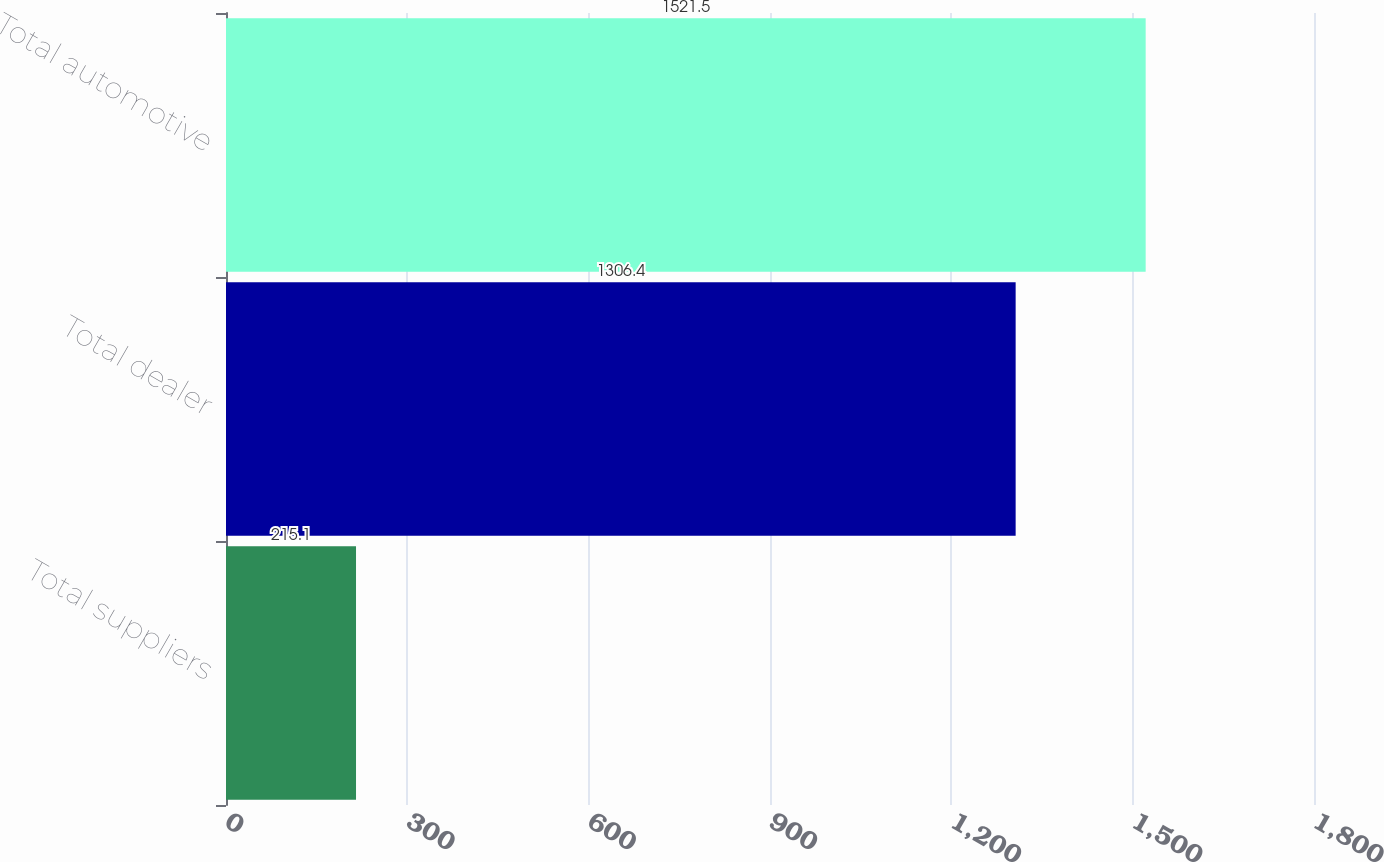<chart> <loc_0><loc_0><loc_500><loc_500><bar_chart><fcel>Total suppliers<fcel>Total dealer<fcel>Total automotive<nl><fcel>215.1<fcel>1306.4<fcel>1521.5<nl></chart> 